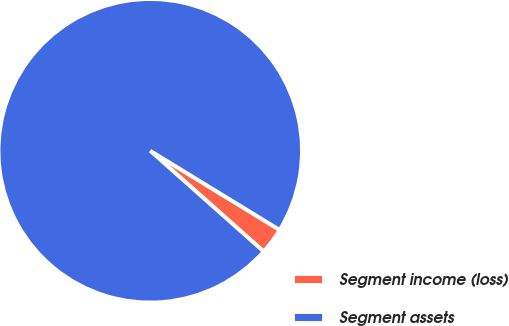<chart> <loc_0><loc_0><loc_500><loc_500><pie_chart><fcel>Segment income (loss)<fcel>Segment assets<nl><fcel>2.82%<fcel>97.18%<nl></chart> 